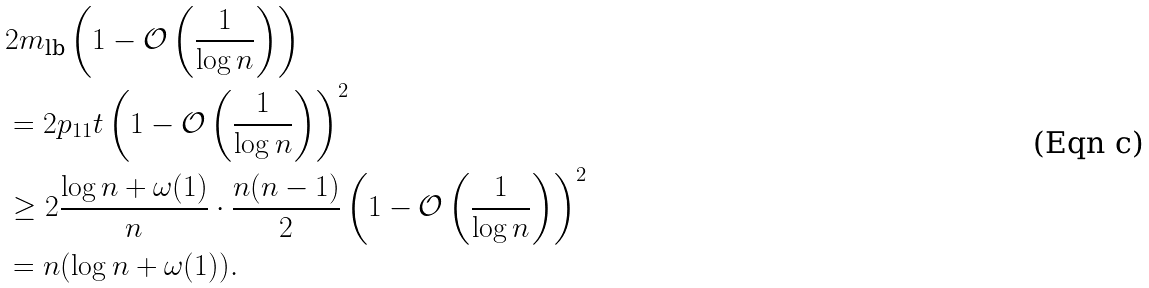<formula> <loc_0><loc_0><loc_500><loc_500>& 2 m _ { \text {lb} } \left ( 1 - \mathcal { O } \left ( \frac { 1 } { \log n } \right ) \right ) \\ & = 2 p _ { 1 1 } t \left ( 1 - \mathcal { O } \left ( \frac { 1 } { \log n } \right ) \right ) ^ { 2 } \\ & \geq 2 \frac { \log n + \omega ( 1 ) } { n } \cdot \frac { n ( n - 1 ) } { 2 } \left ( 1 - \mathcal { O } \left ( \frac { 1 } { \log n } \right ) \right ) ^ { 2 } \\ & = n ( \log n + \omega ( 1 ) ) .</formula> 